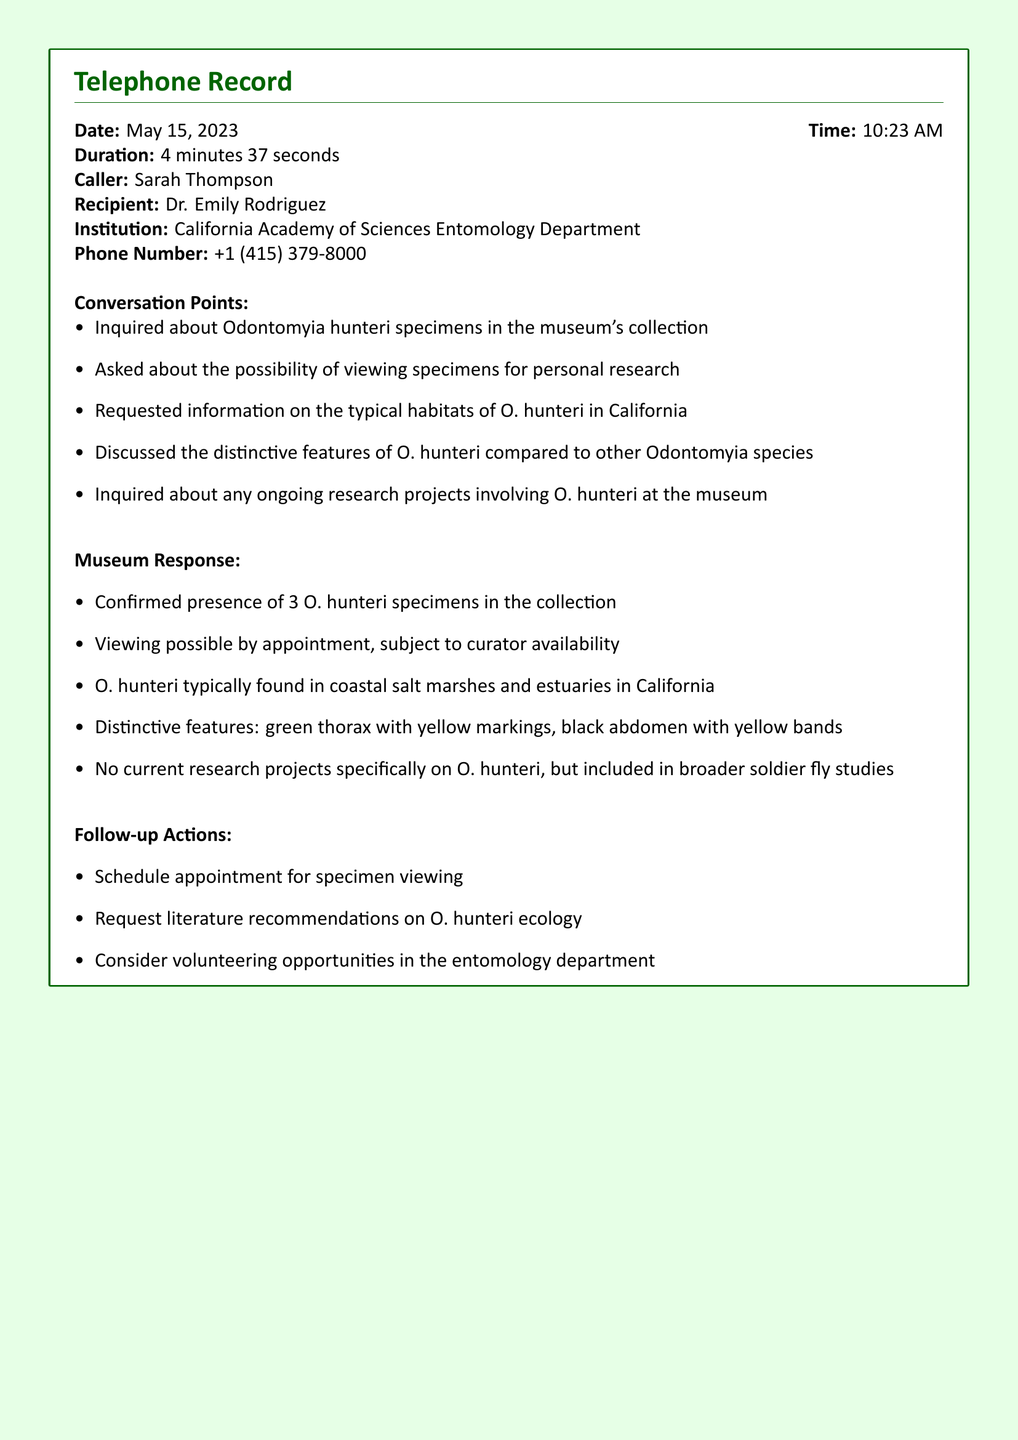What is the date of the call? The date of the call is indicated at the beginning of the document.
Answer: May 15, 2023 Who was the caller? The caller's name is listed prominently in the document.
Answer: Sarah Thompson How many Odontomyia hunteri specimens are in the collection? The document provides the exact number of specimens available.
Answer: 3 What institution did Dr. Emily Rodriguez represent? The document specifies the institution related to the conversation.
Answer: California Academy of Sciences Entomology Department What is the typical habitat of O. hunteri in California? The document includes a specific description of the habitat for O. hunteri.
Answer: Coastal salt marshes and estuaries What are two distinctive features of O. hunteri? The document describes features that differentiate O. hunteri from other species.
Answer: Green thorax with yellow markings, black abdomen with yellow bands What was one follow-up action proposed by the caller? The document lists actions that the caller intended to take after the conversation.
Answer: Schedule appointment for specimen viewing Is there ongoing research specifically on O. hunteri? The document states the status of research projects involving O. hunteri.
Answer: No 